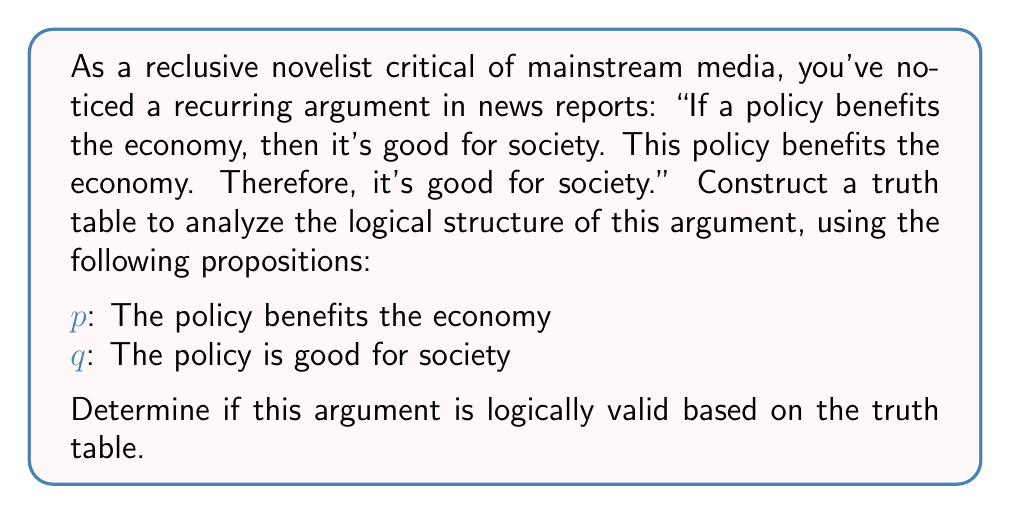Give your solution to this math problem. Let's approach this step-by-step:

1) The argument has two premises and a conclusion:
   Premise 1: $p \rightarrow q$ (If the policy benefits the economy, then it's good for society)
   Premise 2: $p$ (The policy benefits the economy)
   Conclusion: $q$ (The policy is good for society)

2) We need to construct a truth table with columns for $p$, $q$, $p \rightarrow q$, and the entire argument.

3) The truth table:

   $$
   \begin{array}{|c|c|c|c|}
   \hline
   p & q & p \rightarrow q & [(p \rightarrow q) \wedge p] \rightarrow q \\
   \hline
   T & T & T & T \\
   T & F & F & T \\
   F & T & T & T \\
   F & F & T & T \\
   \hline
   \end{array}
   $$

4) Explanation of the columns:
   - The $p \rightarrow q$ column is F only when $p$ is T and $q$ is F.
   - The last column represents the entire argument: if both premises are true ($(p \rightarrow q) \wedge p$), does the conclusion ($q$) follow?

5) Analysis:
   - The argument is valid if the last column is always true, regardless of the truth values of $p$ and $q$.
   - We can see that the last column is indeed always true.

6) Interpretation:
   While the argument is logically valid, as a critical novelist, you might point out that logical validity doesn't guarantee truth in the real world. The argument's soundness depends on the truth of its premises, which could be questioned in complex societal issues.
Answer: The argument is logically valid. 